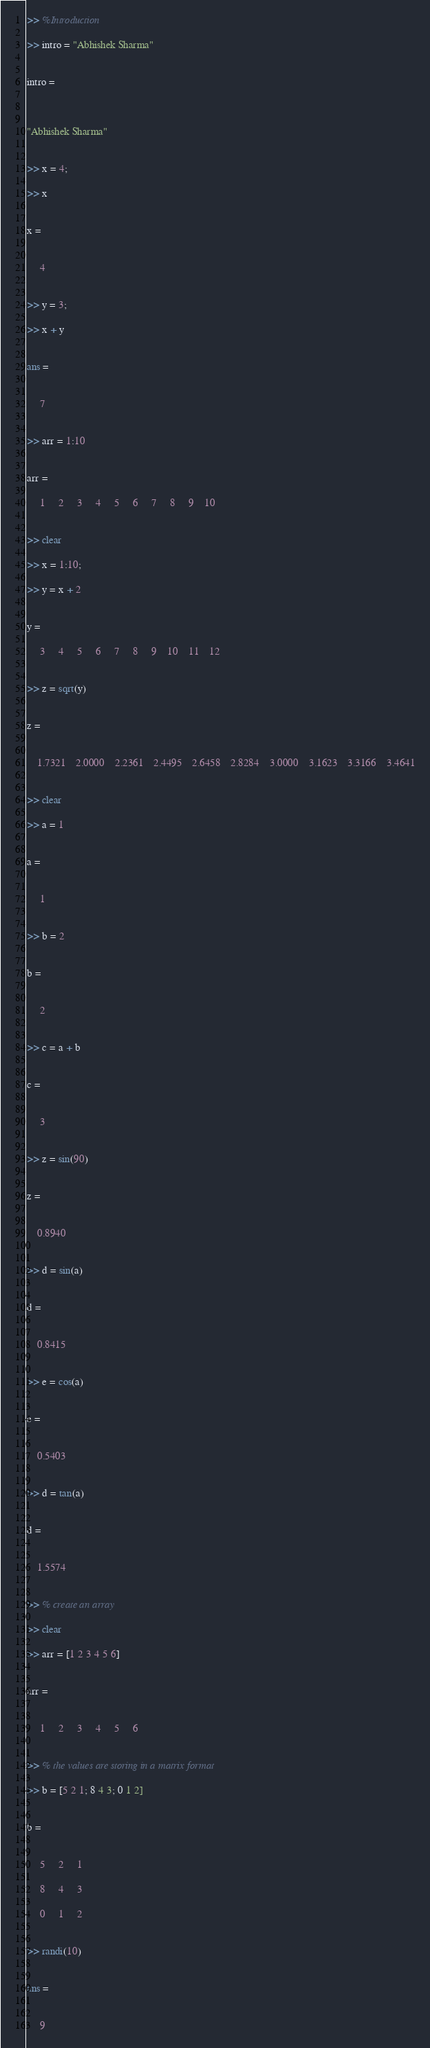Convert code to text. <code><loc_0><loc_0><loc_500><loc_500><_Matlab_>>> %Introduction

>> intro = "Abhishek Sharma"


intro = 

    

"Abhishek Sharma"


>> x = 4;

>> x


x =


     4


>> y = 3;

>> x + y


ans =


     7


>> arr = 1:10


arr =

     1     2     3     4     5     6     7     8     9    10


>> clear

>> x = 1:10;

>> y = x + 2


y =

     3     4     5     6     7     8     9    10    11    12


>> z = sqrt(y)


z =


    1.7321    2.0000    2.2361    2.4495    2.6458    2.8284    3.0000    3.1623    3.3166    3.4641


>> clear

>> a = 1


a =


     1


>> b = 2


b =


     2


>> c = a + b


c =


     3


>> z = sin(90)


z =


    0.8940


>> d = sin(a)


d =


    0.8415


>> e = cos(a)


e =


    0.5403


>> d = tan(a)


d =


    1.5574


>> % create an array

>> clear

>> arr = [1 2 3 4 5 6]


arr =


     1     2     3     4     5     6


>> % the values are storing in a matrix format

>> b = [5 2 1; 8 4 3; 0 1 2]


b =


     5     2     1

     8     4     3

     0     1     2


>> randi(10)


ans =


     9
</code> 